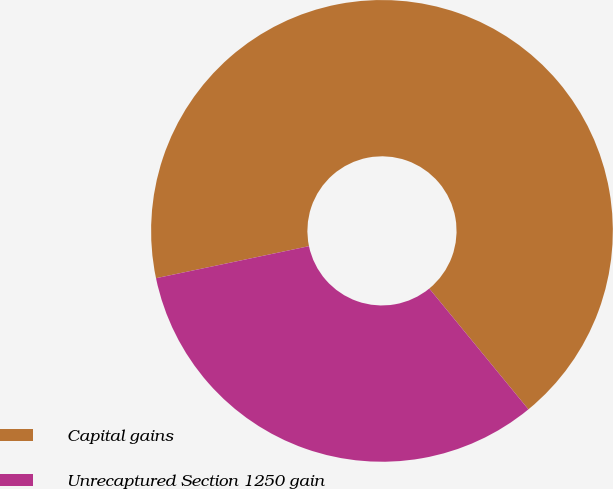<chart> <loc_0><loc_0><loc_500><loc_500><pie_chart><fcel>Capital gains<fcel>Unrecaptured Section 1250 gain<nl><fcel>67.35%<fcel>32.65%<nl></chart> 